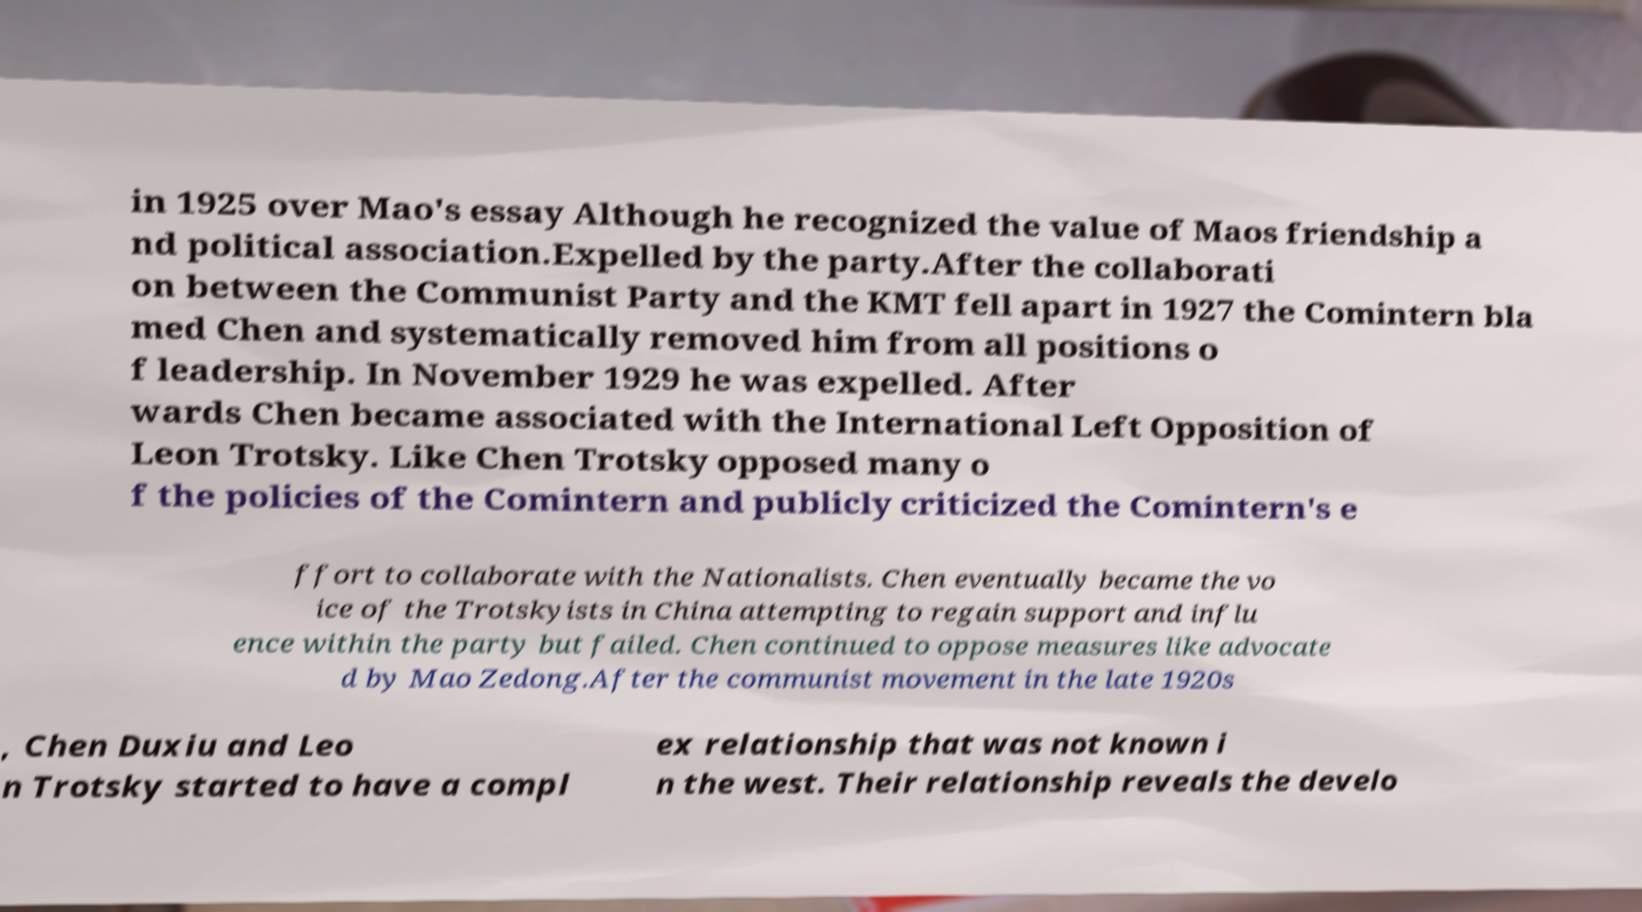Could you extract and type out the text from this image? in 1925 over Mao's essay Although he recognized the value of Maos friendship a nd political association.Expelled by the party.After the collaborati on between the Communist Party and the KMT fell apart in 1927 the Comintern bla med Chen and systematically removed him from all positions o f leadership. In November 1929 he was expelled. After wards Chen became associated with the International Left Opposition of Leon Trotsky. Like Chen Trotsky opposed many o f the policies of the Comintern and publicly criticized the Comintern's e ffort to collaborate with the Nationalists. Chen eventually became the vo ice of the Trotskyists in China attempting to regain support and influ ence within the party but failed. Chen continued to oppose measures like advocate d by Mao Zedong.After the communist movement in the late 1920s , Chen Duxiu and Leo n Trotsky started to have a compl ex relationship that was not known i n the west. Their relationship reveals the develo 